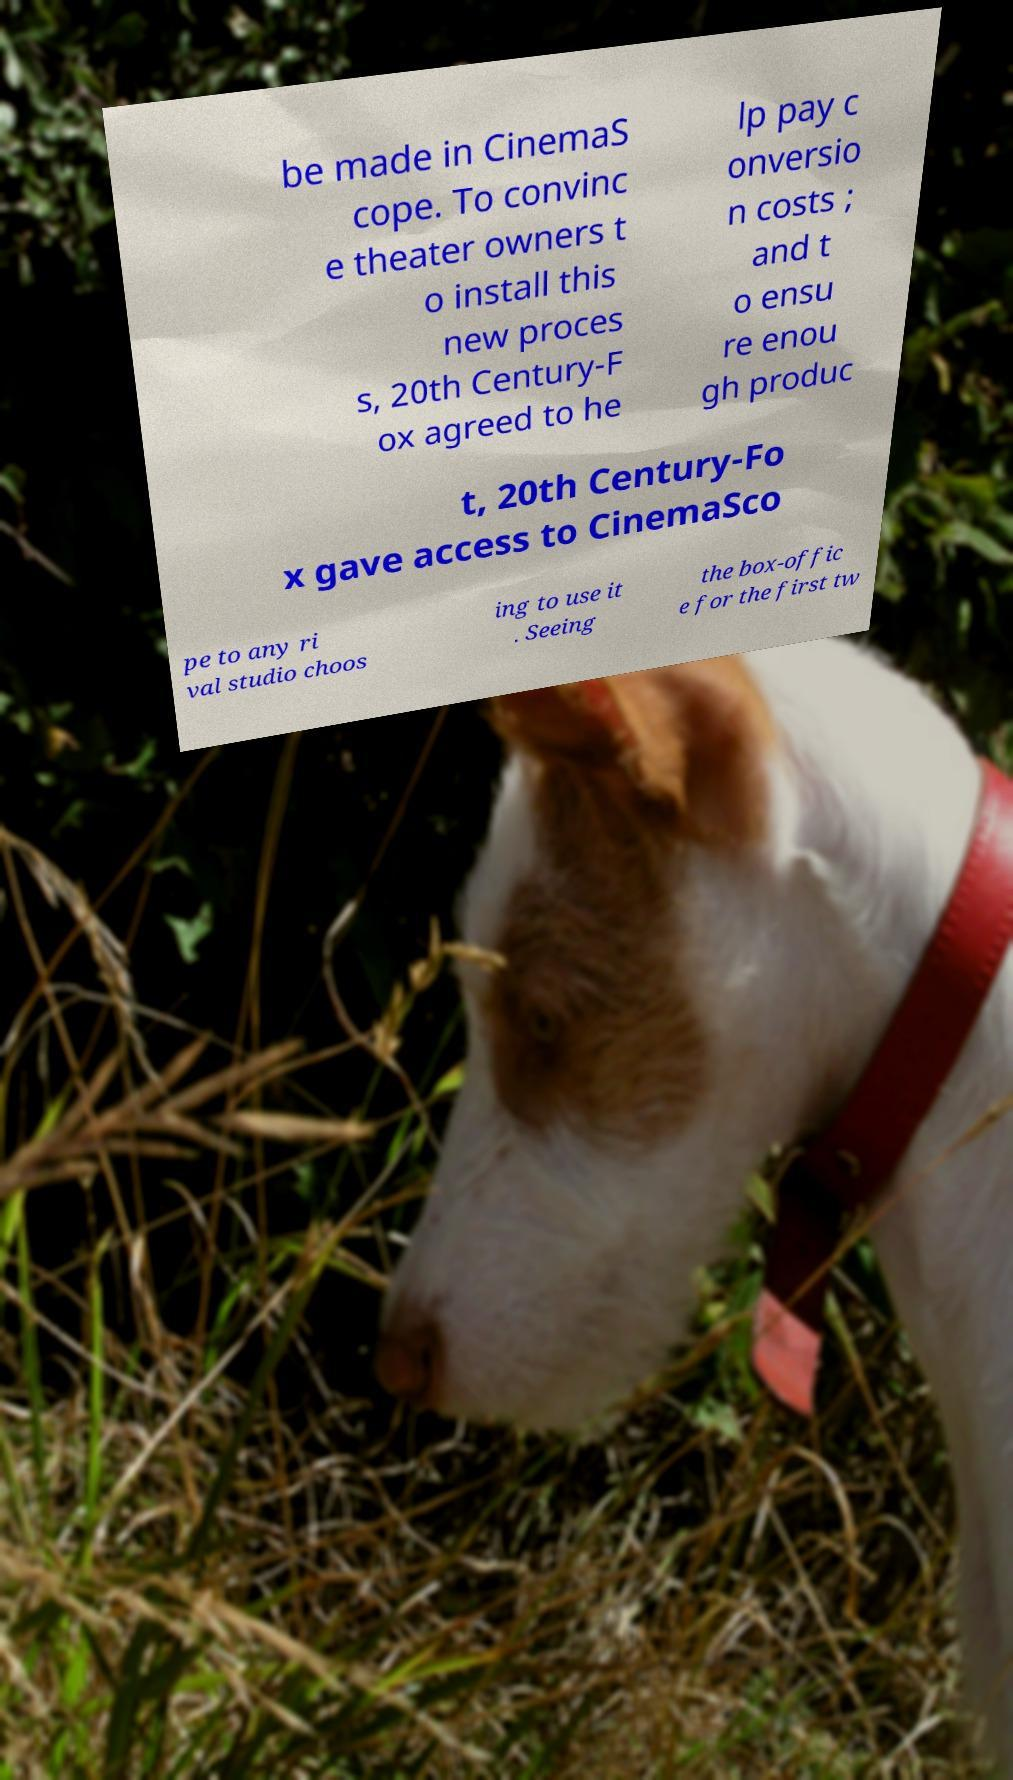What messages or text are displayed in this image? I need them in a readable, typed format. be made in CinemaS cope. To convinc e theater owners t o install this new proces s, 20th Century-F ox agreed to he lp pay c onversio n costs ; and t o ensu re enou gh produc t, 20th Century-Fo x gave access to CinemaSco pe to any ri val studio choos ing to use it . Seeing the box-offic e for the first tw 